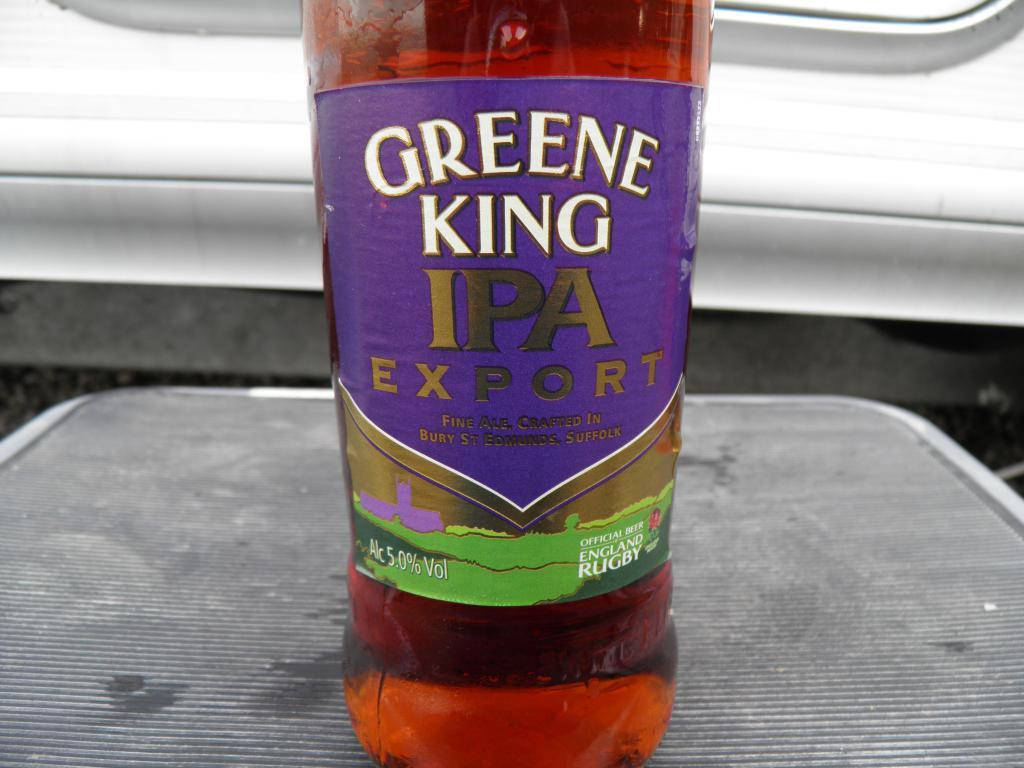What object can be seen in the picture? There is a bottle in the picture. What is inside the bottle? The bottle contains a liquid. Is there any additional information about the bottle? Yes, there is a sticker on the bottle. Where is the bottle located? The bottle is on a table. How many chickens are sitting on the desk in the image? There are no chickens or desks present in the image. 